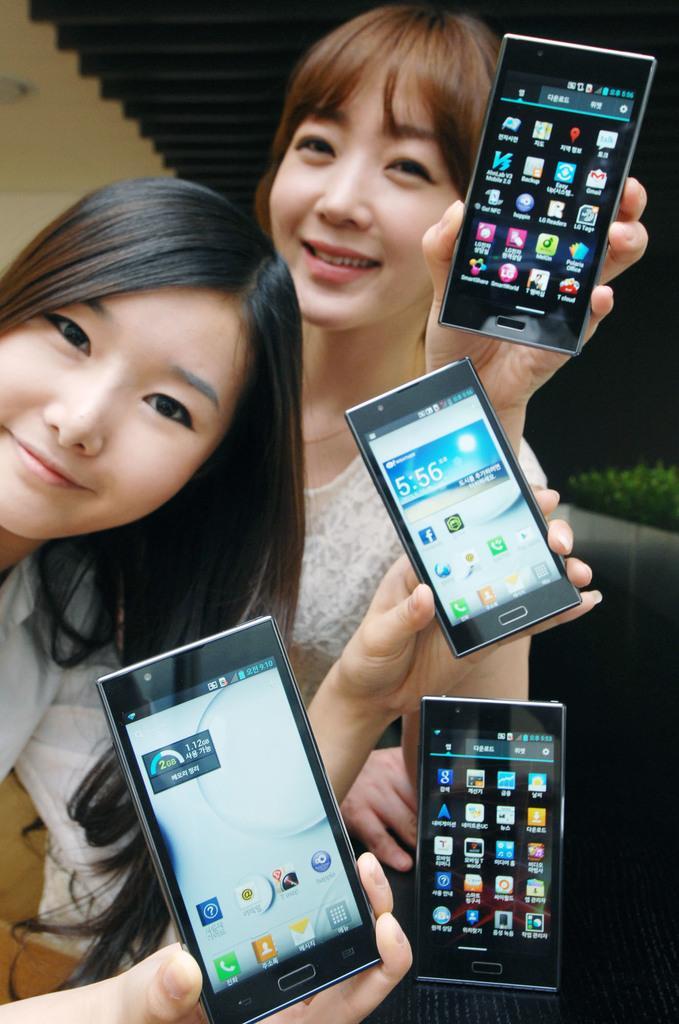Could you give a brief overview of what you see in this image? In this image we can see people holding mobile phones. 